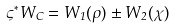Convert formula to latex. <formula><loc_0><loc_0><loc_500><loc_500>\varsigma ^ { * } W _ { C } = W _ { 1 } ( \rho ) \pm W _ { 2 } ( \chi )</formula> 